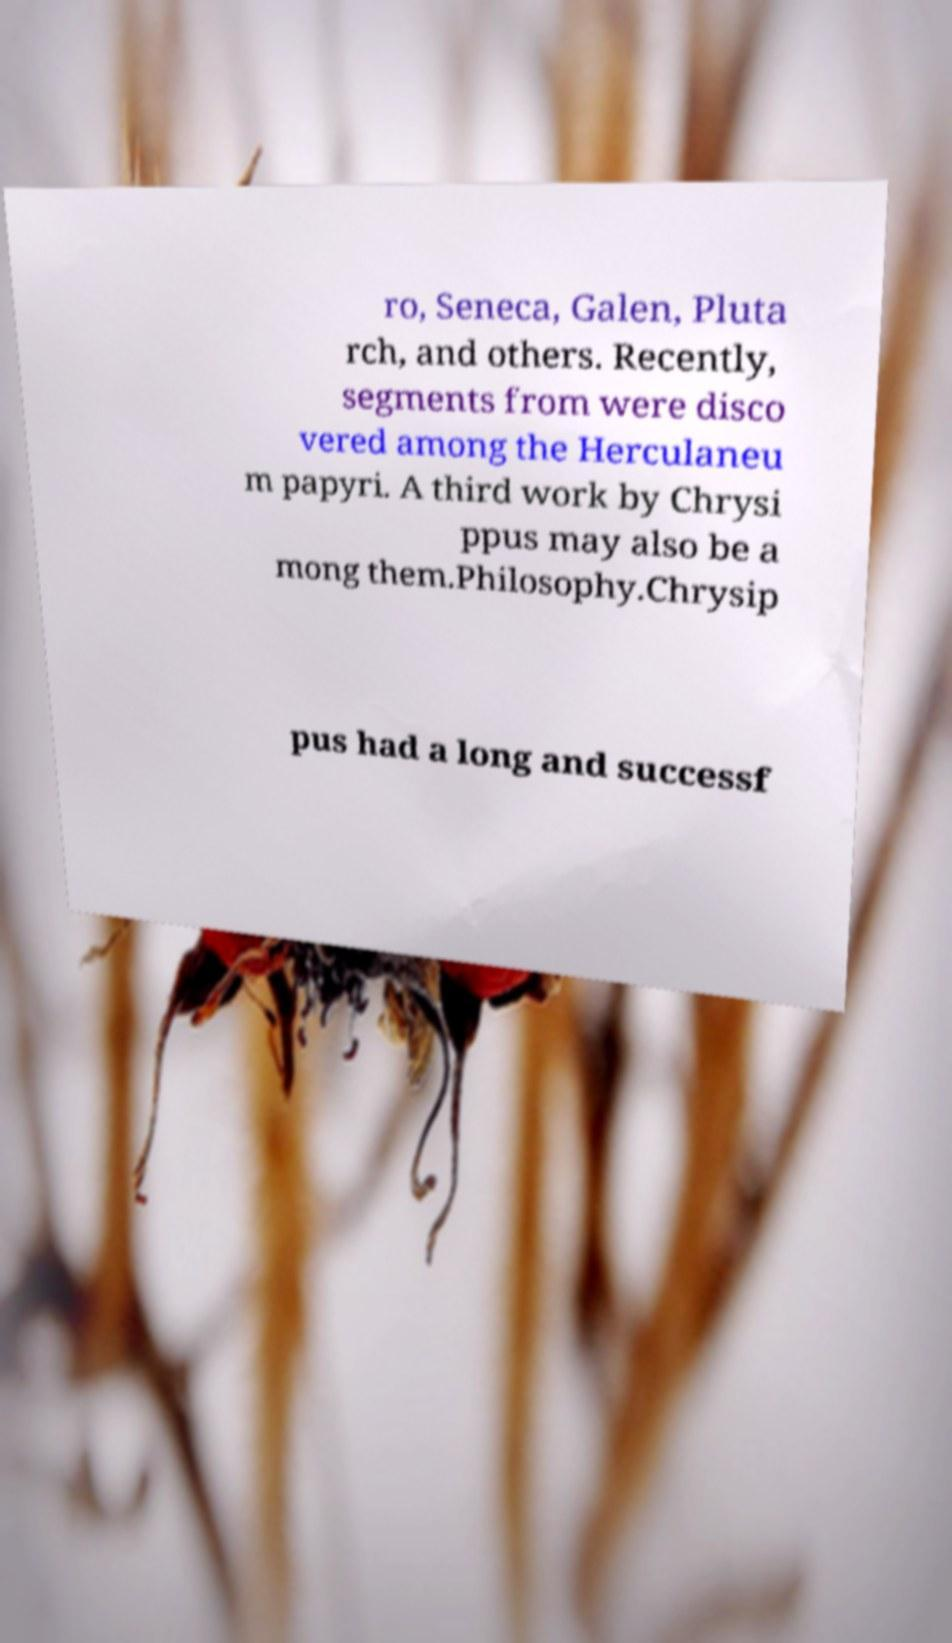Please identify and transcribe the text found in this image. ro, Seneca, Galen, Pluta rch, and others. Recently, segments from were disco vered among the Herculaneu m papyri. A third work by Chrysi ppus may also be a mong them.Philosophy.Chrysip pus had a long and successf 